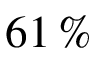Convert formula to latex. <formula><loc_0><loc_0><loc_500><loc_500>6 1 \, \%</formula> 